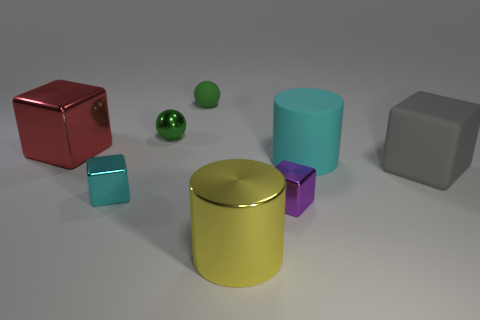Add 1 gray cubes. How many objects exist? 9 Subtract all green cubes. Subtract all brown balls. How many cubes are left? 4 Subtract all spheres. How many objects are left? 6 Subtract 0 cyan spheres. How many objects are left? 8 Subtract all cyan matte cylinders. Subtract all cyan cylinders. How many objects are left? 6 Add 5 large matte blocks. How many large matte blocks are left? 6 Add 1 tiny red metal blocks. How many tiny red metal blocks exist? 1 